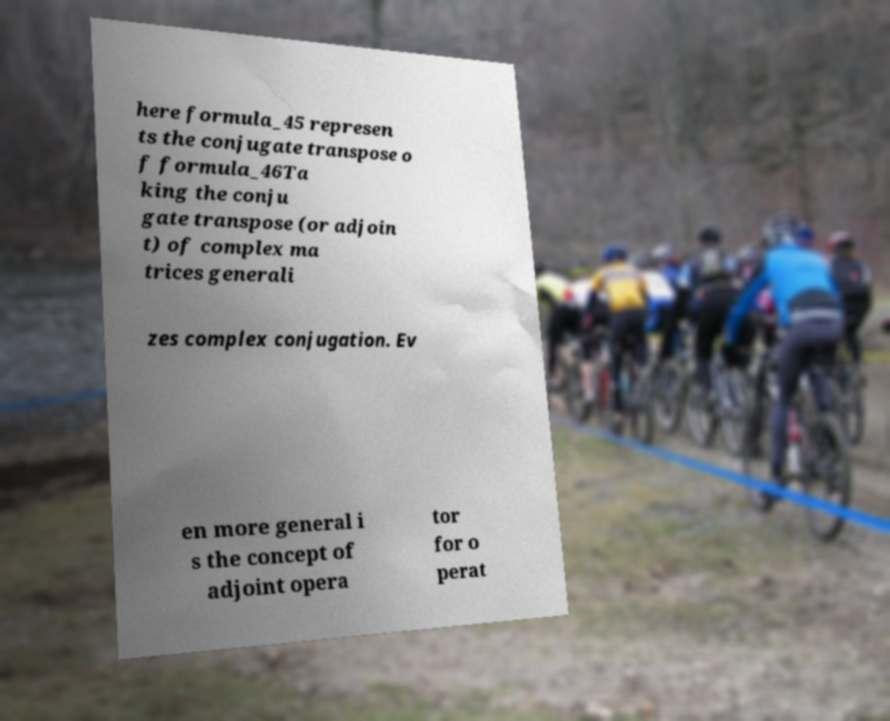Could you assist in decoding the text presented in this image and type it out clearly? here formula_45 represen ts the conjugate transpose o f formula_46Ta king the conju gate transpose (or adjoin t) of complex ma trices generali zes complex conjugation. Ev en more general i s the concept of adjoint opera tor for o perat 